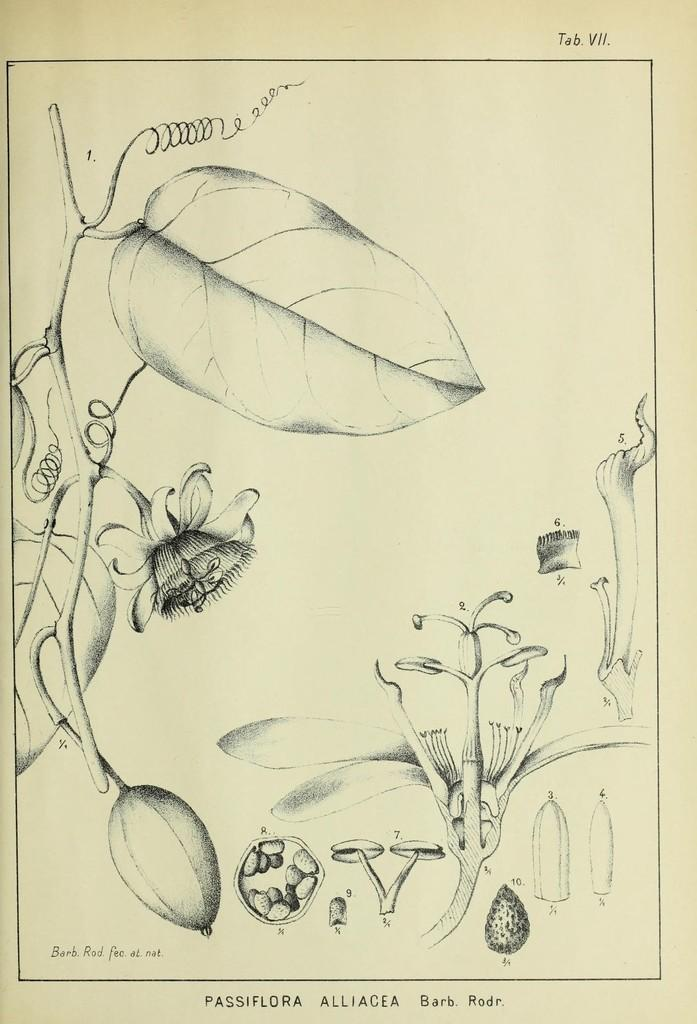What is the main subject of the paper in the image? The main subject of the paper in the image is related to plants, as it contains images of leaves, a creeper, a flower, and parts of a plant. Can you describe the images on the paper? Yes, there are images of leaves, a creeper, a flower, and parts of a plant on the paper. Is there any text on the paper? Yes, there is text on the paper. What type of arithmetic problem can be seen solved on the paper? There is no arithmetic problem visible on the paper; it contains images and text related to plants. What organization is responsible for the content on the paper? There is no information about an organization responsible for the content on the paper in the image. 